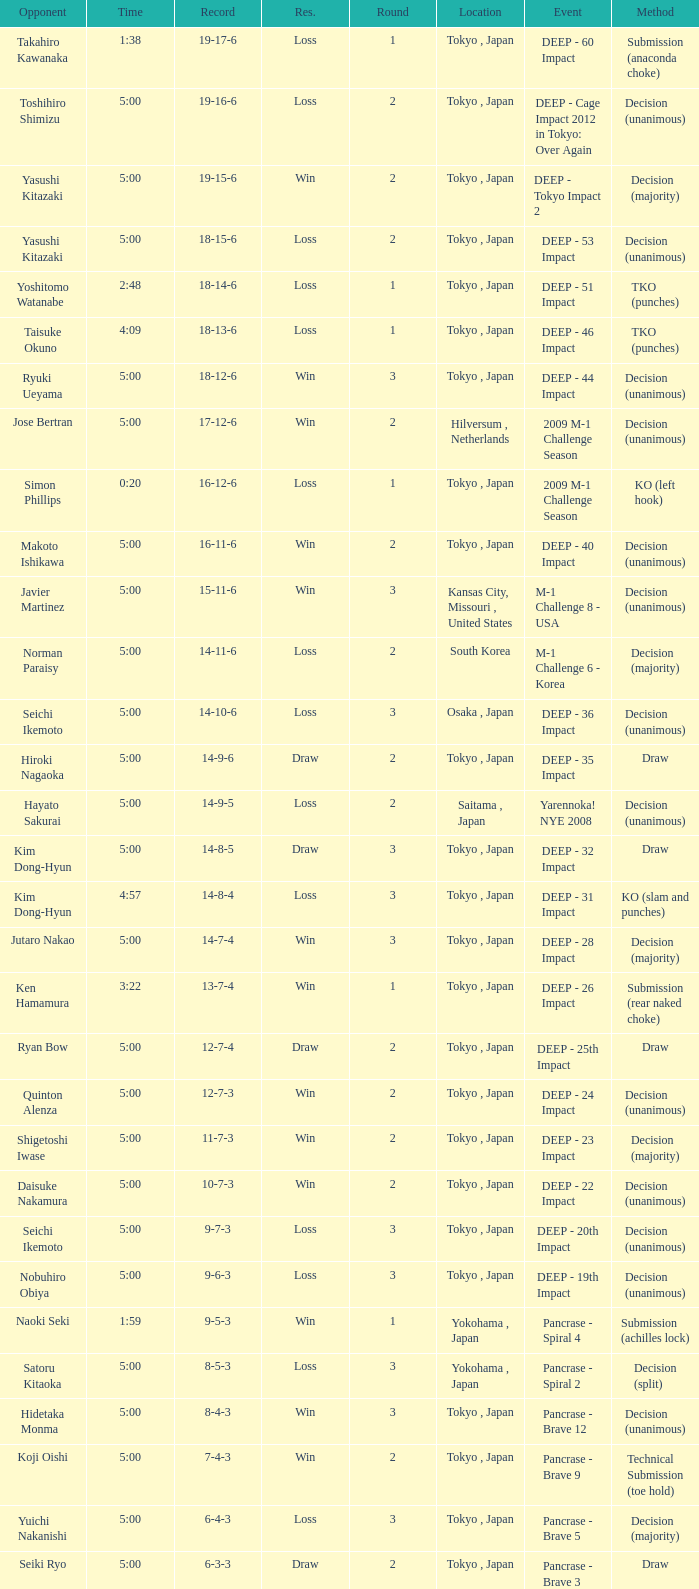What is the location when the method is tko (punches) and the time is 2:48? Tokyo , Japan. 